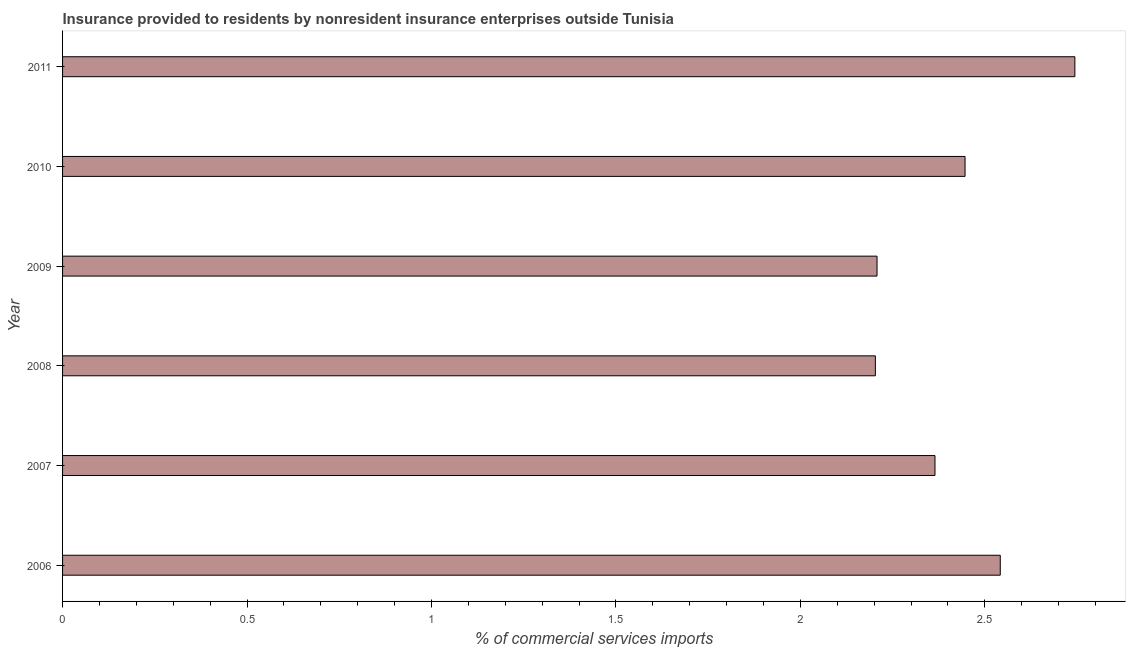What is the title of the graph?
Offer a terse response. Insurance provided to residents by nonresident insurance enterprises outside Tunisia. What is the label or title of the X-axis?
Your response must be concise. % of commercial services imports. What is the label or title of the Y-axis?
Provide a short and direct response. Year. What is the insurance provided by non-residents in 2011?
Provide a short and direct response. 2.74. Across all years, what is the maximum insurance provided by non-residents?
Your response must be concise. 2.74. Across all years, what is the minimum insurance provided by non-residents?
Provide a succinct answer. 2.2. In which year was the insurance provided by non-residents maximum?
Give a very brief answer. 2011. In which year was the insurance provided by non-residents minimum?
Provide a succinct answer. 2008. What is the sum of the insurance provided by non-residents?
Provide a succinct answer. 14.51. What is the difference between the insurance provided by non-residents in 2009 and 2010?
Your response must be concise. -0.24. What is the average insurance provided by non-residents per year?
Provide a short and direct response. 2.42. What is the median insurance provided by non-residents?
Make the answer very short. 2.41. Do a majority of the years between 2011 and 2007 (inclusive) have insurance provided by non-residents greater than 1.2 %?
Your response must be concise. Yes. What is the ratio of the insurance provided by non-residents in 2009 to that in 2011?
Ensure brevity in your answer.  0.81. What is the difference between the highest and the second highest insurance provided by non-residents?
Your answer should be compact. 0.2. What is the difference between the highest and the lowest insurance provided by non-residents?
Provide a succinct answer. 0.54. In how many years, is the insurance provided by non-residents greater than the average insurance provided by non-residents taken over all years?
Offer a very short reply. 3. How many bars are there?
Your answer should be compact. 6. How many years are there in the graph?
Offer a terse response. 6. What is the difference between two consecutive major ticks on the X-axis?
Provide a succinct answer. 0.5. What is the % of commercial services imports of 2006?
Your answer should be very brief. 2.54. What is the % of commercial services imports of 2007?
Your answer should be very brief. 2.36. What is the % of commercial services imports of 2008?
Offer a terse response. 2.2. What is the % of commercial services imports of 2009?
Ensure brevity in your answer.  2.21. What is the % of commercial services imports in 2010?
Your answer should be very brief. 2.45. What is the % of commercial services imports of 2011?
Provide a short and direct response. 2.74. What is the difference between the % of commercial services imports in 2006 and 2007?
Your response must be concise. 0.18. What is the difference between the % of commercial services imports in 2006 and 2008?
Your response must be concise. 0.34. What is the difference between the % of commercial services imports in 2006 and 2009?
Your answer should be compact. 0.33. What is the difference between the % of commercial services imports in 2006 and 2010?
Provide a succinct answer. 0.1. What is the difference between the % of commercial services imports in 2006 and 2011?
Give a very brief answer. -0.2. What is the difference between the % of commercial services imports in 2007 and 2008?
Give a very brief answer. 0.16. What is the difference between the % of commercial services imports in 2007 and 2009?
Your answer should be compact. 0.16. What is the difference between the % of commercial services imports in 2007 and 2010?
Offer a very short reply. -0.08. What is the difference between the % of commercial services imports in 2007 and 2011?
Your answer should be compact. -0.38. What is the difference between the % of commercial services imports in 2008 and 2009?
Ensure brevity in your answer.  -0. What is the difference between the % of commercial services imports in 2008 and 2010?
Give a very brief answer. -0.24. What is the difference between the % of commercial services imports in 2008 and 2011?
Your answer should be very brief. -0.54. What is the difference between the % of commercial services imports in 2009 and 2010?
Give a very brief answer. -0.24. What is the difference between the % of commercial services imports in 2009 and 2011?
Your answer should be compact. -0.54. What is the difference between the % of commercial services imports in 2010 and 2011?
Provide a short and direct response. -0.3. What is the ratio of the % of commercial services imports in 2006 to that in 2007?
Offer a terse response. 1.07. What is the ratio of the % of commercial services imports in 2006 to that in 2008?
Your response must be concise. 1.15. What is the ratio of the % of commercial services imports in 2006 to that in 2009?
Give a very brief answer. 1.15. What is the ratio of the % of commercial services imports in 2006 to that in 2010?
Ensure brevity in your answer.  1.04. What is the ratio of the % of commercial services imports in 2006 to that in 2011?
Give a very brief answer. 0.93. What is the ratio of the % of commercial services imports in 2007 to that in 2008?
Offer a terse response. 1.07. What is the ratio of the % of commercial services imports in 2007 to that in 2009?
Your response must be concise. 1.07. What is the ratio of the % of commercial services imports in 2007 to that in 2011?
Offer a very short reply. 0.86. What is the ratio of the % of commercial services imports in 2008 to that in 2009?
Ensure brevity in your answer.  1. What is the ratio of the % of commercial services imports in 2008 to that in 2010?
Ensure brevity in your answer.  0.9. What is the ratio of the % of commercial services imports in 2008 to that in 2011?
Your response must be concise. 0.8. What is the ratio of the % of commercial services imports in 2009 to that in 2010?
Ensure brevity in your answer.  0.9. What is the ratio of the % of commercial services imports in 2009 to that in 2011?
Make the answer very short. 0.81. What is the ratio of the % of commercial services imports in 2010 to that in 2011?
Ensure brevity in your answer.  0.89. 